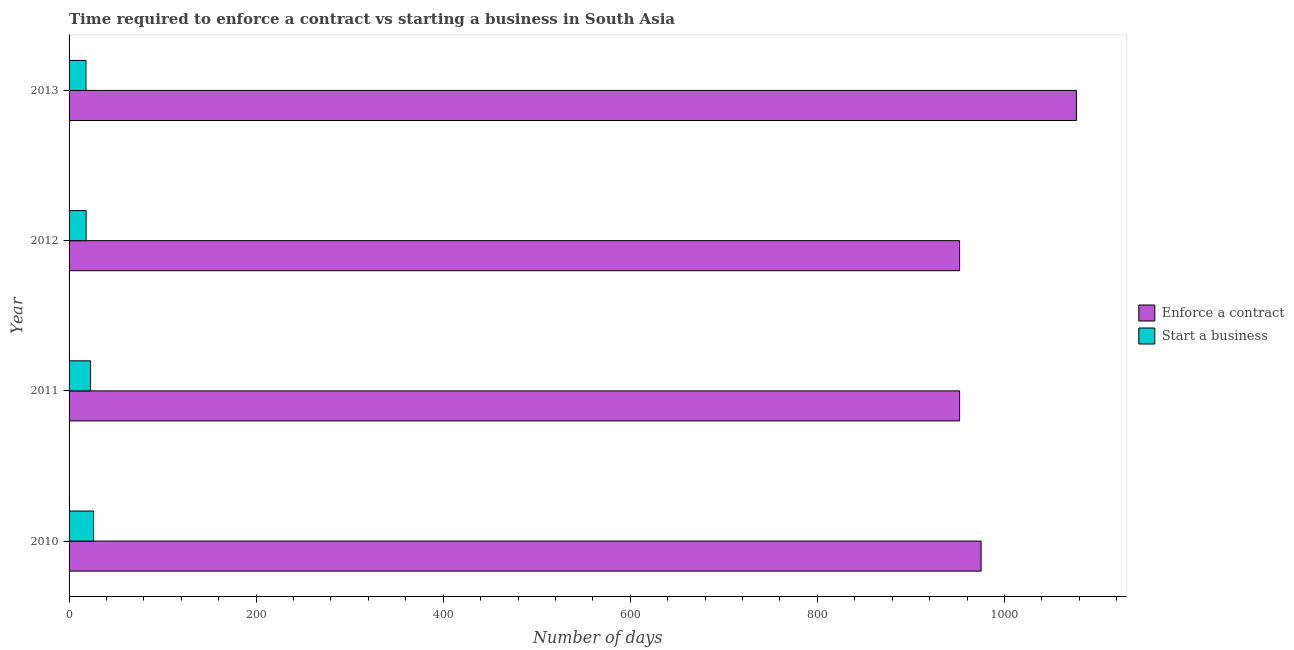How many different coloured bars are there?
Your response must be concise. 2. Are the number of bars per tick equal to the number of legend labels?
Provide a short and direct response. Yes. How many bars are there on the 4th tick from the bottom?
Provide a succinct answer. 2. What is the label of the 3rd group of bars from the top?
Make the answer very short. 2011. In how many cases, is the number of bars for a given year not equal to the number of legend labels?
Offer a terse response. 0. Across all years, what is the maximum number of days to enforece a contract?
Make the answer very short. 1076.9. Across all years, what is the minimum number of days to enforece a contract?
Ensure brevity in your answer.  952. In which year was the number of days to start a business minimum?
Your response must be concise. 2013. What is the total number of days to start a business in the graph?
Keep it short and to the point. 85.46. What is the difference between the number of days to enforece a contract in 2012 and that in 2013?
Provide a succinct answer. -124.9. What is the difference between the number of days to start a business in 2010 and the number of days to enforece a contract in 2011?
Provide a short and direct response. -925.8. What is the average number of days to start a business per year?
Ensure brevity in your answer.  21.37. In the year 2013, what is the difference between the number of days to enforece a contract and number of days to start a business?
Provide a short and direct response. 1058.84. In how many years, is the number of days to start a business greater than 520 days?
Provide a succinct answer. 0. What is the ratio of the number of days to start a business in 2010 to that in 2011?
Offer a very short reply. 1.14. What is the difference between the highest and the second highest number of days to enforece a contract?
Make the answer very short. 101.9. What is the difference between the highest and the lowest number of days to start a business?
Ensure brevity in your answer.  8.14. Is the sum of the number of days to enforece a contract in 2010 and 2013 greater than the maximum number of days to start a business across all years?
Your response must be concise. Yes. What does the 1st bar from the top in 2010 represents?
Offer a very short reply. Start a business. What does the 1st bar from the bottom in 2013 represents?
Offer a terse response. Enforce a contract. How many bars are there?
Your answer should be compact. 8. How many years are there in the graph?
Provide a succinct answer. 4. What is the difference between two consecutive major ticks on the X-axis?
Offer a very short reply. 200. Are the values on the major ticks of X-axis written in scientific E-notation?
Give a very brief answer. No. Does the graph contain any zero values?
Offer a very short reply. No. Where does the legend appear in the graph?
Your answer should be compact. Center right. What is the title of the graph?
Provide a short and direct response. Time required to enforce a contract vs starting a business in South Asia. Does "Girls" appear as one of the legend labels in the graph?
Give a very brief answer. No. What is the label or title of the X-axis?
Your answer should be very brief. Number of days. What is the Number of days in Enforce a contract in 2010?
Your response must be concise. 975. What is the Number of days of Start a business in 2010?
Offer a very short reply. 26.2. What is the Number of days in Enforce a contract in 2011?
Your answer should be compact. 952. What is the Number of days of Start a business in 2011?
Your response must be concise. 23. What is the Number of days in Enforce a contract in 2012?
Keep it short and to the point. 952. What is the Number of days of Enforce a contract in 2013?
Provide a short and direct response. 1076.9. What is the Number of days in Start a business in 2013?
Keep it short and to the point. 18.06. Across all years, what is the maximum Number of days of Enforce a contract?
Your answer should be compact. 1076.9. Across all years, what is the maximum Number of days in Start a business?
Provide a succinct answer. 26.2. Across all years, what is the minimum Number of days in Enforce a contract?
Keep it short and to the point. 952. Across all years, what is the minimum Number of days of Start a business?
Provide a succinct answer. 18.06. What is the total Number of days of Enforce a contract in the graph?
Ensure brevity in your answer.  3955.9. What is the total Number of days of Start a business in the graph?
Give a very brief answer. 85.46. What is the difference between the Number of days of Enforce a contract in 2010 and that in 2011?
Your answer should be compact. 23. What is the difference between the Number of days of Enforce a contract in 2010 and that in 2012?
Your answer should be very brief. 23. What is the difference between the Number of days in Enforce a contract in 2010 and that in 2013?
Keep it short and to the point. -101.9. What is the difference between the Number of days of Start a business in 2010 and that in 2013?
Keep it short and to the point. 8.14. What is the difference between the Number of days of Enforce a contract in 2011 and that in 2012?
Make the answer very short. 0. What is the difference between the Number of days of Start a business in 2011 and that in 2012?
Your response must be concise. 4.8. What is the difference between the Number of days in Enforce a contract in 2011 and that in 2013?
Give a very brief answer. -124.9. What is the difference between the Number of days of Start a business in 2011 and that in 2013?
Your response must be concise. 4.94. What is the difference between the Number of days in Enforce a contract in 2012 and that in 2013?
Ensure brevity in your answer.  -124.9. What is the difference between the Number of days of Start a business in 2012 and that in 2013?
Offer a very short reply. 0.14. What is the difference between the Number of days in Enforce a contract in 2010 and the Number of days in Start a business in 2011?
Offer a terse response. 952. What is the difference between the Number of days in Enforce a contract in 2010 and the Number of days in Start a business in 2012?
Your response must be concise. 956.8. What is the difference between the Number of days of Enforce a contract in 2010 and the Number of days of Start a business in 2013?
Provide a short and direct response. 956.94. What is the difference between the Number of days of Enforce a contract in 2011 and the Number of days of Start a business in 2012?
Make the answer very short. 933.8. What is the difference between the Number of days of Enforce a contract in 2011 and the Number of days of Start a business in 2013?
Your response must be concise. 933.94. What is the difference between the Number of days of Enforce a contract in 2012 and the Number of days of Start a business in 2013?
Your response must be concise. 933.94. What is the average Number of days of Enforce a contract per year?
Offer a terse response. 988.98. What is the average Number of days in Start a business per year?
Keep it short and to the point. 21.37. In the year 2010, what is the difference between the Number of days of Enforce a contract and Number of days of Start a business?
Give a very brief answer. 948.8. In the year 2011, what is the difference between the Number of days of Enforce a contract and Number of days of Start a business?
Offer a terse response. 929. In the year 2012, what is the difference between the Number of days in Enforce a contract and Number of days in Start a business?
Your answer should be compact. 933.8. In the year 2013, what is the difference between the Number of days of Enforce a contract and Number of days of Start a business?
Offer a terse response. 1058.84. What is the ratio of the Number of days in Enforce a contract in 2010 to that in 2011?
Give a very brief answer. 1.02. What is the ratio of the Number of days in Start a business in 2010 to that in 2011?
Offer a terse response. 1.14. What is the ratio of the Number of days in Enforce a contract in 2010 to that in 2012?
Ensure brevity in your answer.  1.02. What is the ratio of the Number of days in Start a business in 2010 to that in 2012?
Make the answer very short. 1.44. What is the ratio of the Number of days in Enforce a contract in 2010 to that in 2013?
Your response must be concise. 0.91. What is the ratio of the Number of days in Start a business in 2010 to that in 2013?
Ensure brevity in your answer.  1.45. What is the ratio of the Number of days in Enforce a contract in 2011 to that in 2012?
Keep it short and to the point. 1. What is the ratio of the Number of days of Start a business in 2011 to that in 2012?
Provide a short and direct response. 1.26. What is the ratio of the Number of days of Enforce a contract in 2011 to that in 2013?
Keep it short and to the point. 0.88. What is the ratio of the Number of days in Start a business in 2011 to that in 2013?
Provide a short and direct response. 1.27. What is the ratio of the Number of days of Enforce a contract in 2012 to that in 2013?
Give a very brief answer. 0.88. What is the ratio of the Number of days in Start a business in 2012 to that in 2013?
Your response must be concise. 1.01. What is the difference between the highest and the second highest Number of days in Enforce a contract?
Offer a terse response. 101.9. What is the difference between the highest and the second highest Number of days in Start a business?
Give a very brief answer. 3.2. What is the difference between the highest and the lowest Number of days in Enforce a contract?
Ensure brevity in your answer.  124.9. What is the difference between the highest and the lowest Number of days of Start a business?
Offer a very short reply. 8.14. 